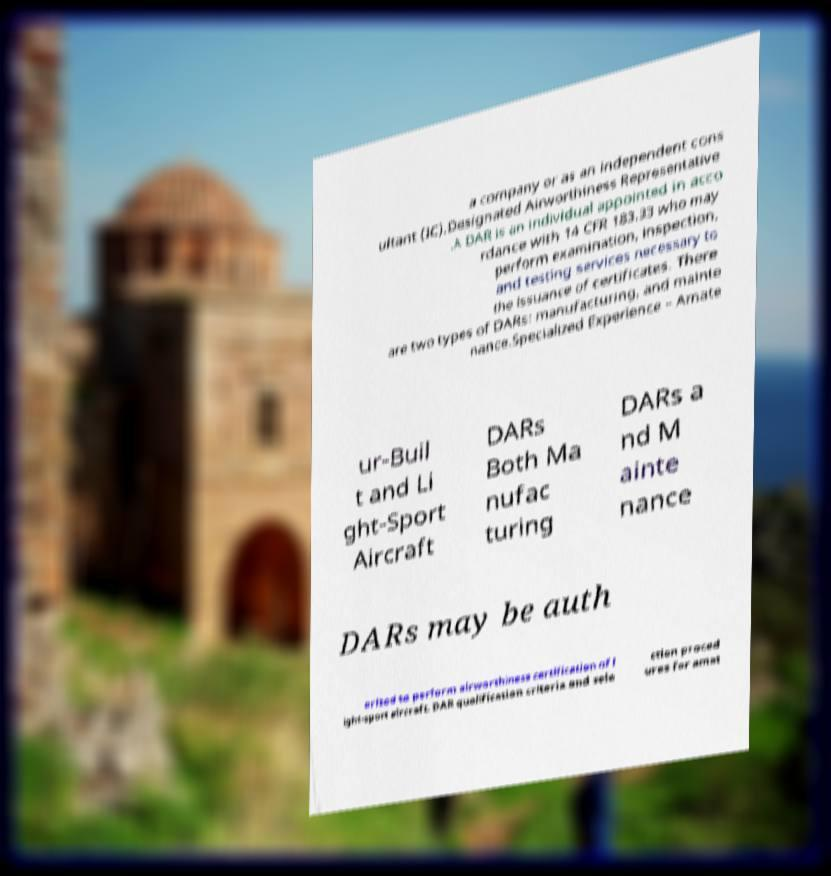Please identify and transcribe the text found in this image. a company or as an independent cons ultant (IC).Designated Airworthiness Representative .A DAR is an individual appointed in acco rdance with 14 CFR 183.33 who may perform examination, inspection, and testing services necessary to the issuance of certificates. There are two types of DARs: manufacturing, and mainte nance.Specialized Experience – Amate ur-Buil t and Li ght-Sport Aircraft DARs Both Ma nufac turing DARs a nd M ainte nance DARs may be auth orized to perform airworthiness certification of l ight-sport aircraft. DAR qualification criteria and sele ction proced ures for amat 